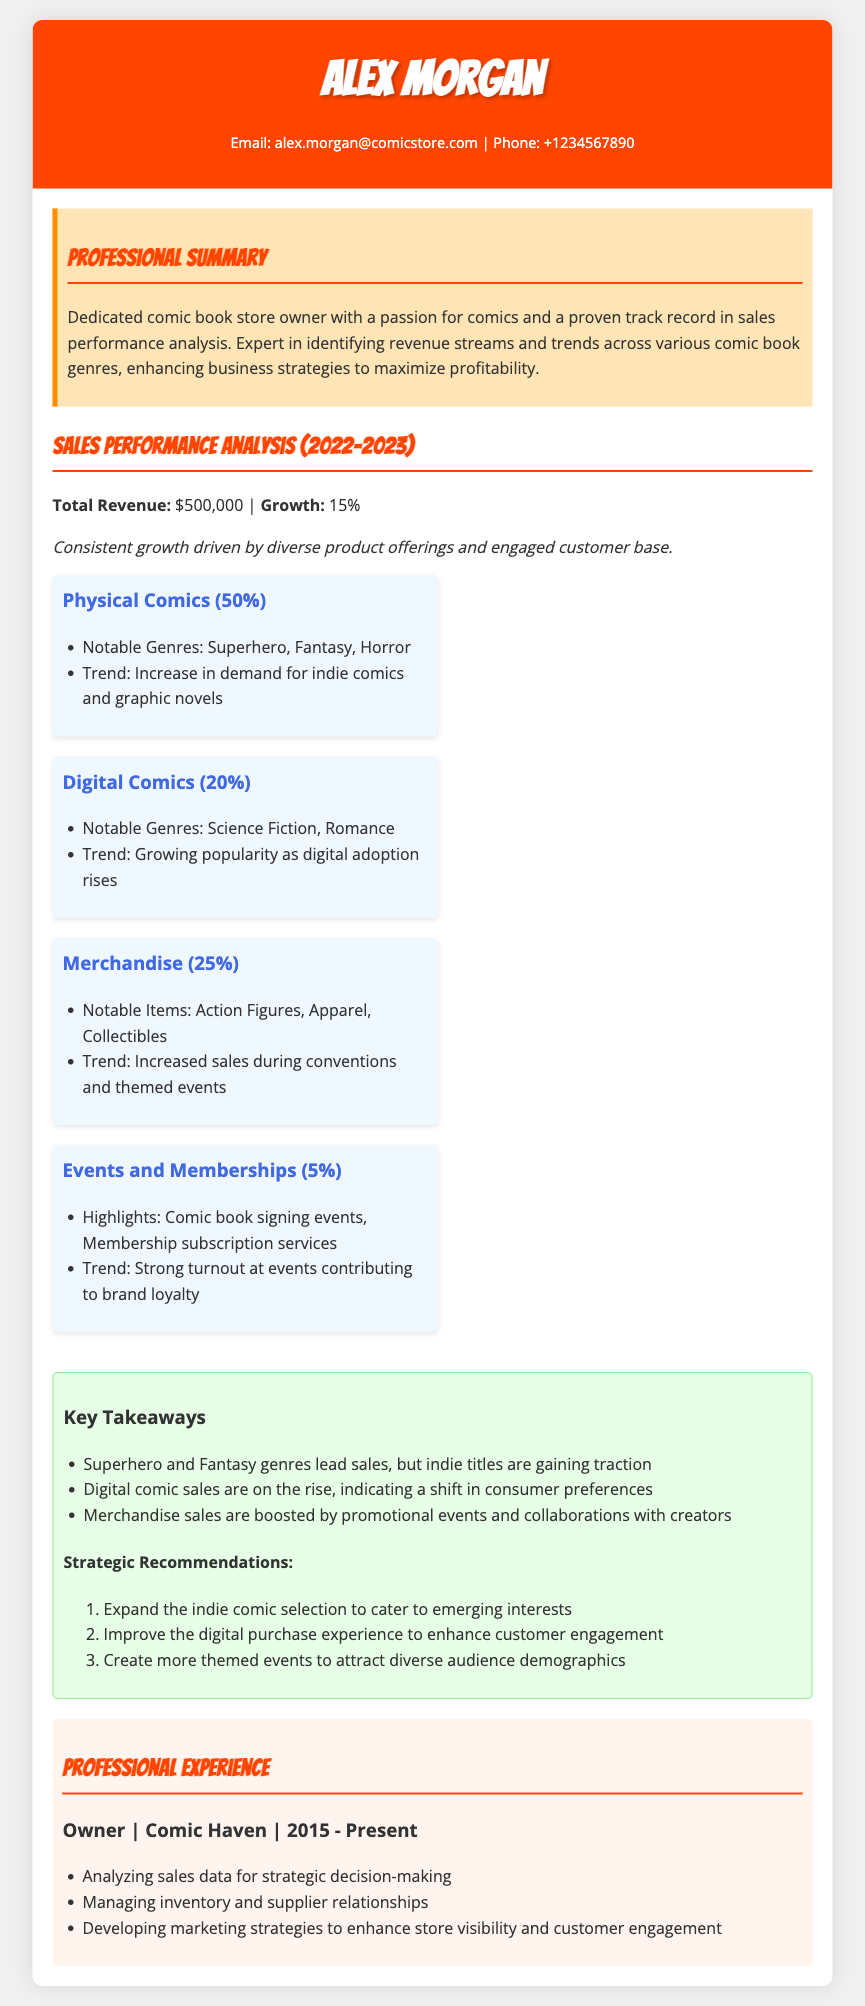what is the total revenue? The total revenue is stated in the document as $500,000.
Answer: $500,000 what is the growth percentage? The document indicates that the growth percentage for the year is 15%.
Answer: 15% what percentage of revenue comes from physical comics? The document allocated 50% of total revenue to physical comics.
Answer: 50% what notable genres are highlighted for physical comics? The notable genres mentioned for physical comics are Superhero, Fantasy, and Horror.
Answer: Superhero, Fantasy, Horror what revenue percentage is attributed to events and memberships? The document states that events and memberships account for 5% of total revenue.
Answer: 5% which genre is gaining traction according to the key takeaways? The document notes that indie titles are gaining traction in comic book sales.
Answer: indie titles how does digital comic sales trend according to the analysis? The analysis indicates that digital comic sales are on the rise, showing a shift in consumer preferences.
Answer: on the rise what is Alex Morgan's role at Comic Haven? Alex Morgan's role at Comic Haven is stated as Owner.
Answer: Owner what specific recommendation is made regarding indie comics? The document recommends expanding the indie comic selection to cater to emerging interests.
Answer: Expand the indie comic selection 